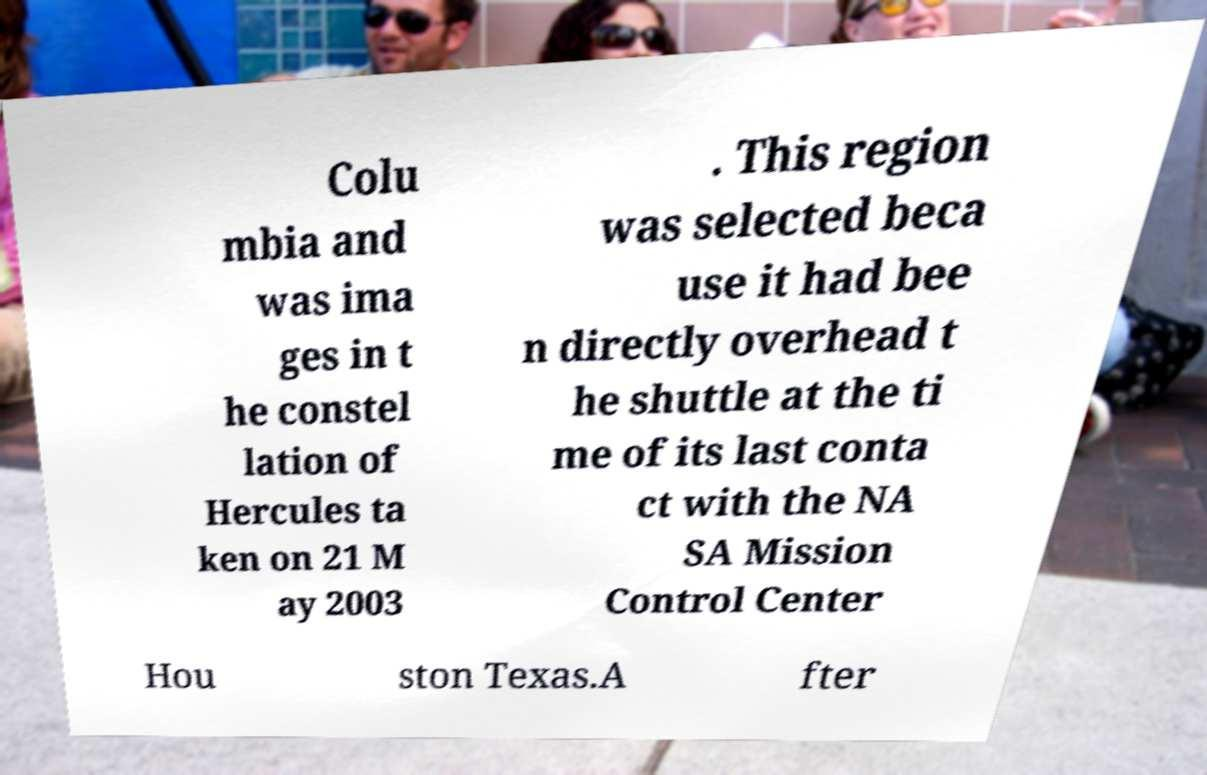What messages or text are displayed in this image? I need them in a readable, typed format. Colu mbia and was ima ges in t he constel lation of Hercules ta ken on 21 M ay 2003 . This region was selected beca use it had bee n directly overhead t he shuttle at the ti me of its last conta ct with the NA SA Mission Control Center Hou ston Texas.A fter 